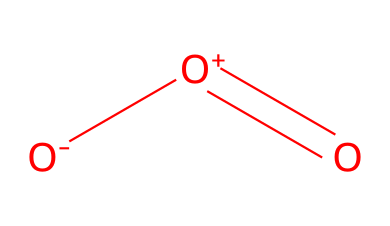What is the molecular formula of this chemical? The chemical structure displays three oxygen atoms (O), giving us the molecular formula O3.
Answer: O3 How many bonds are present in the ozone molecule? In ozone, there are a total of two bonds: one double bond and one single bond. This includes the central atom being connected to two other oxygen atoms.
Answer: 2 What is the molecular geometry around the central oxygen in ozone? The central oxygen atom is surrounded by two other oxygen atoms, which leads to a bent shape due to the presence of lone pairs on the central oxygen.
Answer: bent What charge do the oxygen atoms exhibit in ozone? The representation indicates the presence of a negatively charged oxygen ([O-]) and a positively charged oxygen ([O+]), which highlights the charge distribution in the molecule.
Answer: negative and positive In what processes is ozone commonly utilized as an oxidizer? Ozone is widely used in industrial processes for air and water purification, due to its strong oxidizing properties that effectively break down pollutants.
Answer: air and water purification What functional role does ozone serve as an oxidizer? Ozone acts as a strong oxidizing agent, meaning it can donate electrons and facilitate the breakdown of organic materials and pathogens in purification processes.
Answer: oxidizing agent How does the number of oxygen atoms relate to ozone's reactivity? The presence of three oxygen atoms in its structure allows ozone to engage in multiple reactions, enhancing its reactivity compared to diatomic oxygen (O2).
Answer: enhances reactivity 